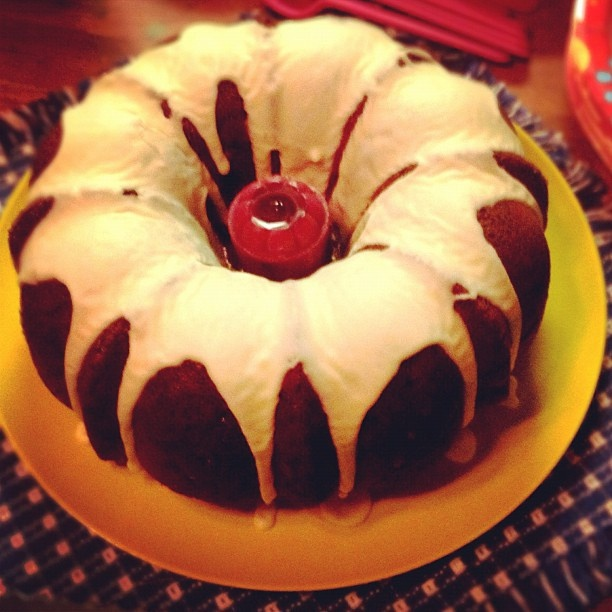Describe the objects in this image and their specific colors. I can see dining table in khaki, black, maroon, and tan tones and cake in maroon, khaki, black, and tan tones in this image. 